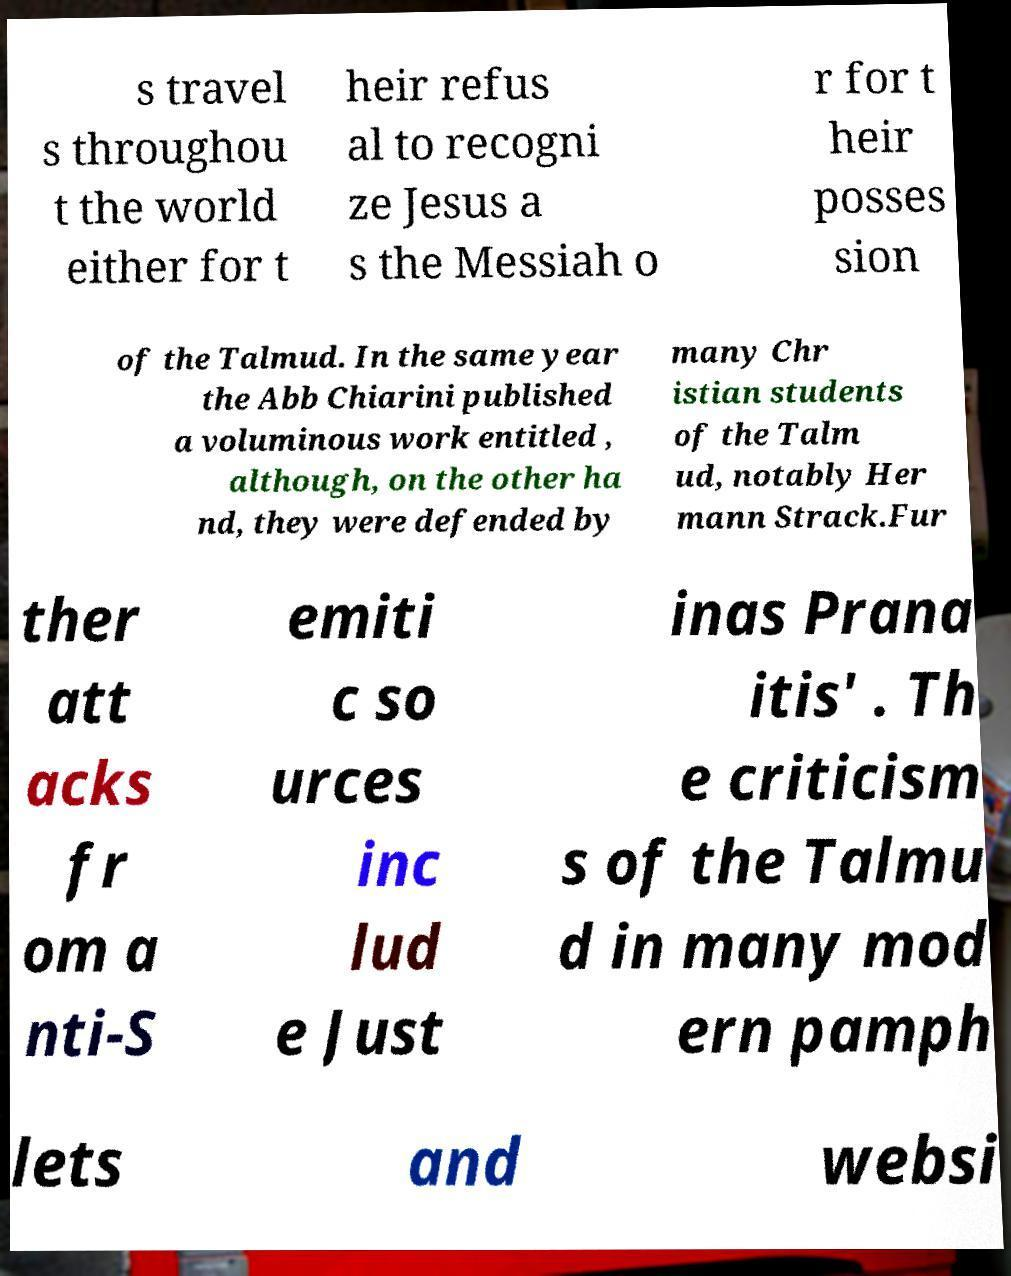For documentation purposes, I need the text within this image transcribed. Could you provide that? s travel s throughou t the world either for t heir refus al to recogni ze Jesus a s the Messiah o r for t heir posses sion of the Talmud. In the same year the Abb Chiarini published a voluminous work entitled , although, on the other ha nd, they were defended by many Chr istian students of the Talm ud, notably Her mann Strack.Fur ther att acks fr om a nti-S emiti c so urces inc lud e Just inas Prana itis' . Th e criticism s of the Talmu d in many mod ern pamph lets and websi 